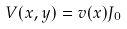Convert formula to latex. <formula><loc_0><loc_0><loc_500><loc_500>V ( x , y ) = v ( x ) J _ { 0 }</formula> 